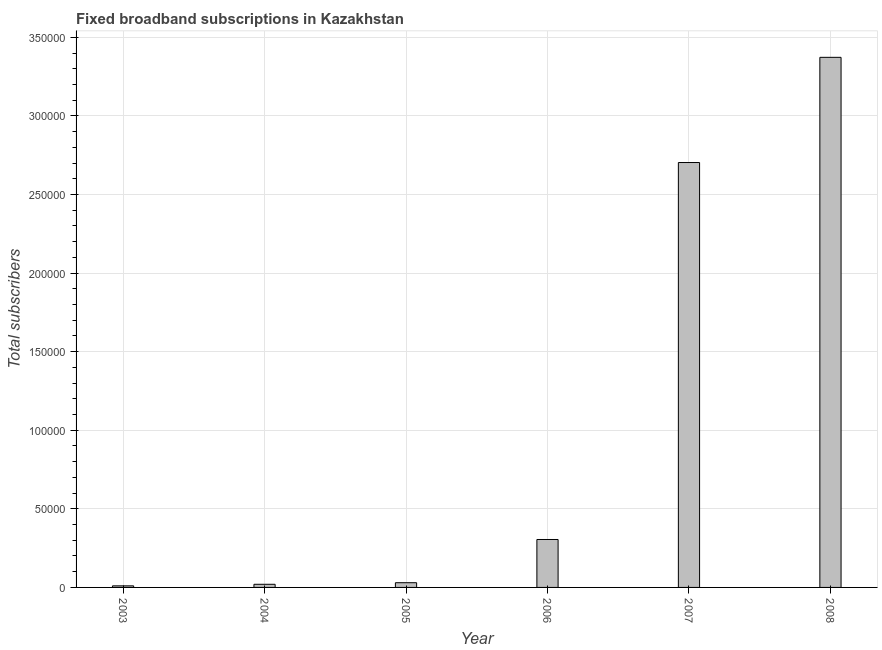Does the graph contain grids?
Offer a terse response. Yes. What is the title of the graph?
Provide a short and direct response. Fixed broadband subscriptions in Kazakhstan. What is the label or title of the Y-axis?
Provide a succinct answer. Total subscribers. What is the total number of fixed broadband subscriptions in 2005?
Provide a short and direct response. 2996. Across all years, what is the maximum total number of fixed broadband subscriptions?
Make the answer very short. 3.37e+05. Across all years, what is the minimum total number of fixed broadband subscriptions?
Make the answer very short. 998. In which year was the total number of fixed broadband subscriptions minimum?
Your answer should be very brief. 2003. What is the sum of the total number of fixed broadband subscriptions?
Offer a very short reply. 6.44e+05. What is the difference between the total number of fixed broadband subscriptions in 2007 and 2008?
Your response must be concise. -6.69e+04. What is the average total number of fixed broadband subscriptions per year?
Provide a succinct answer. 1.07e+05. What is the median total number of fixed broadband subscriptions?
Your response must be concise. 1.67e+04. Do a majority of the years between 2008 and 2006 (inclusive) have total number of fixed broadband subscriptions greater than 160000 ?
Offer a very short reply. Yes. Is the difference between the total number of fixed broadband subscriptions in 2003 and 2006 greater than the difference between any two years?
Offer a terse response. No. What is the difference between the highest and the second highest total number of fixed broadband subscriptions?
Make the answer very short. 6.69e+04. Is the sum of the total number of fixed broadband subscriptions in 2004 and 2008 greater than the maximum total number of fixed broadband subscriptions across all years?
Keep it short and to the point. Yes. What is the difference between the highest and the lowest total number of fixed broadband subscriptions?
Your response must be concise. 3.36e+05. How many bars are there?
Ensure brevity in your answer.  6. Are all the bars in the graph horizontal?
Provide a short and direct response. No. What is the difference between two consecutive major ticks on the Y-axis?
Provide a succinct answer. 5.00e+04. What is the Total subscribers in 2003?
Offer a terse response. 998. What is the Total subscribers of 2004?
Provide a succinct answer. 1997. What is the Total subscribers of 2005?
Your answer should be very brief. 2996. What is the Total subscribers in 2006?
Offer a terse response. 3.05e+04. What is the Total subscribers in 2007?
Provide a succinct answer. 2.70e+05. What is the Total subscribers of 2008?
Your answer should be compact. 3.37e+05. What is the difference between the Total subscribers in 2003 and 2004?
Give a very brief answer. -999. What is the difference between the Total subscribers in 2003 and 2005?
Keep it short and to the point. -1998. What is the difference between the Total subscribers in 2003 and 2006?
Provide a succinct answer. -2.95e+04. What is the difference between the Total subscribers in 2003 and 2007?
Your answer should be compact. -2.69e+05. What is the difference between the Total subscribers in 2003 and 2008?
Ensure brevity in your answer.  -3.36e+05. What is the difference between the Total subscribers in 2004 and 2005?
Your answer should be very brief. -999. What is the difference between the Total subscribers in 2004 and 2006?
Your response must be concise. -2.85e+04. What is the difference between the Total subscribers in 2004 and 2007?
Offer a terse response. -2.68e+05. What is the difference between the Total subscribers in 2004 and 2008?
Give a very brief answer. -3.35e+05. What is the difference between the Total subscribers in 2005 and 2006?
Your answer should be very brief. -2.75e+04. What is the difference between the Total subscribers in 2005 and 2007?
Ensure brevity in your answer.  -2.67e+05. What is the difference between the Total subscribers in 2005 and 2008?
Ensure brevity in your answer.  -3.34e+05. What is the difference between the Total subscribers in 2006 and 2007?
Your answer should be very brief. -2.40e+05. What is the difference between the Total subscribers in 2006 and 2008?
Ensure brevity in your answer.  -3.07e+05. What is the difference between the Total subscribers in 2007 and 2008?
Make the answer very short. -6.69e+04. What is the ratio of the Total subscribers in 2003 to that in 2004?
Ensure brevity in your answer.  0.5. What is the ratio of the Total subscribers in 2003 to that in 2005?
Make the answer very short. 0.33. What is the ratio of the Total subscribers in 2003 to that in 2006?
Your answer should be very brief. 0.03. What is the ratio of the Total subscribers in 2003 to that in 2007?
Your answer should be very brief. 0. What is the ratio of the Total subscribers in 2003 to that in 2008?
Your answer should be compact. 0. What is the ratio of the Total subscribers in 2004 to that in 2005?
Provide a short and direct response. 0.67. What is the ratio of the Total subscribers in 2004 to that in 2006?
Your response must be concise. 0.07. What is the ratio of the Total subscribers in 2004 to that in 2007?
Your answer should be compact. 0.01. What is the ratio of the Total subscribers in 2004 to that in 2008?
Your answer should be very brief. 0.01. What is the ratio of the Total subscribers in 2005 to that in 2006?
Your answer should be very brief. 0.1. What is the ratio of the Total subscribers in 2005 to that in 2007?
Give a very brief answer. 0.01. What is the ratio of the Total subscribers in 2005 to that in 2008?
Keep it short and to the point. 0.01. What is the ratio of the Total subscribers in 2006 to that in 2007?
Your response must be concise. 0.11. What is the ratio of the Total subscribers in 2006 to that in 2008?
Provide a succinct answer. 0.09. What is the ratio of the Total subscribers in 2007 to that in 2008?
Provide a succinct answer. 0.8. 